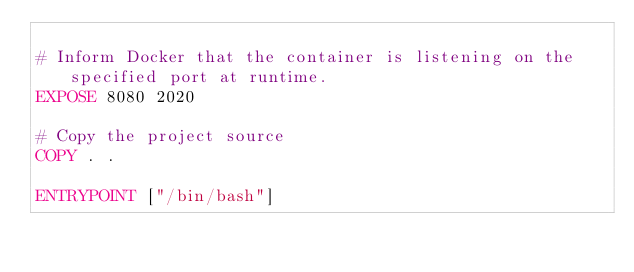Convert code to text. <code><loc_0><loc_0><loc_500><loc_500><_Dockerfile_>
# Inform Docker that the container is listening on the specified port at runtime.
EXPOSE 8080 2020

# Copy the project source
COPY . .

ENTRYPOINT ["/bin/bash"]
</code> 